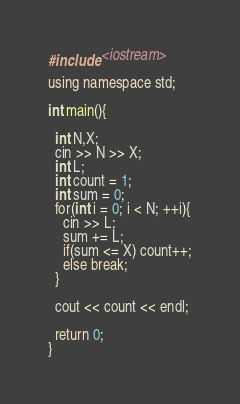<code> <loc_0><loc_0><loc_500><loc_500><_C++_>#include <iostream>

using namespace std;

int main(){
 
  int N,X;
  cin >> N >> X;
  int L;
  int count = 1;
  int sum = 0;
  for(int i = 0; i < N; ++i){
    cin >> L;
    sum += L;
    if(sum <= X) count++;
    else break;
  }
  
  cout << count << endl;
  
  return 0;
}</code> 